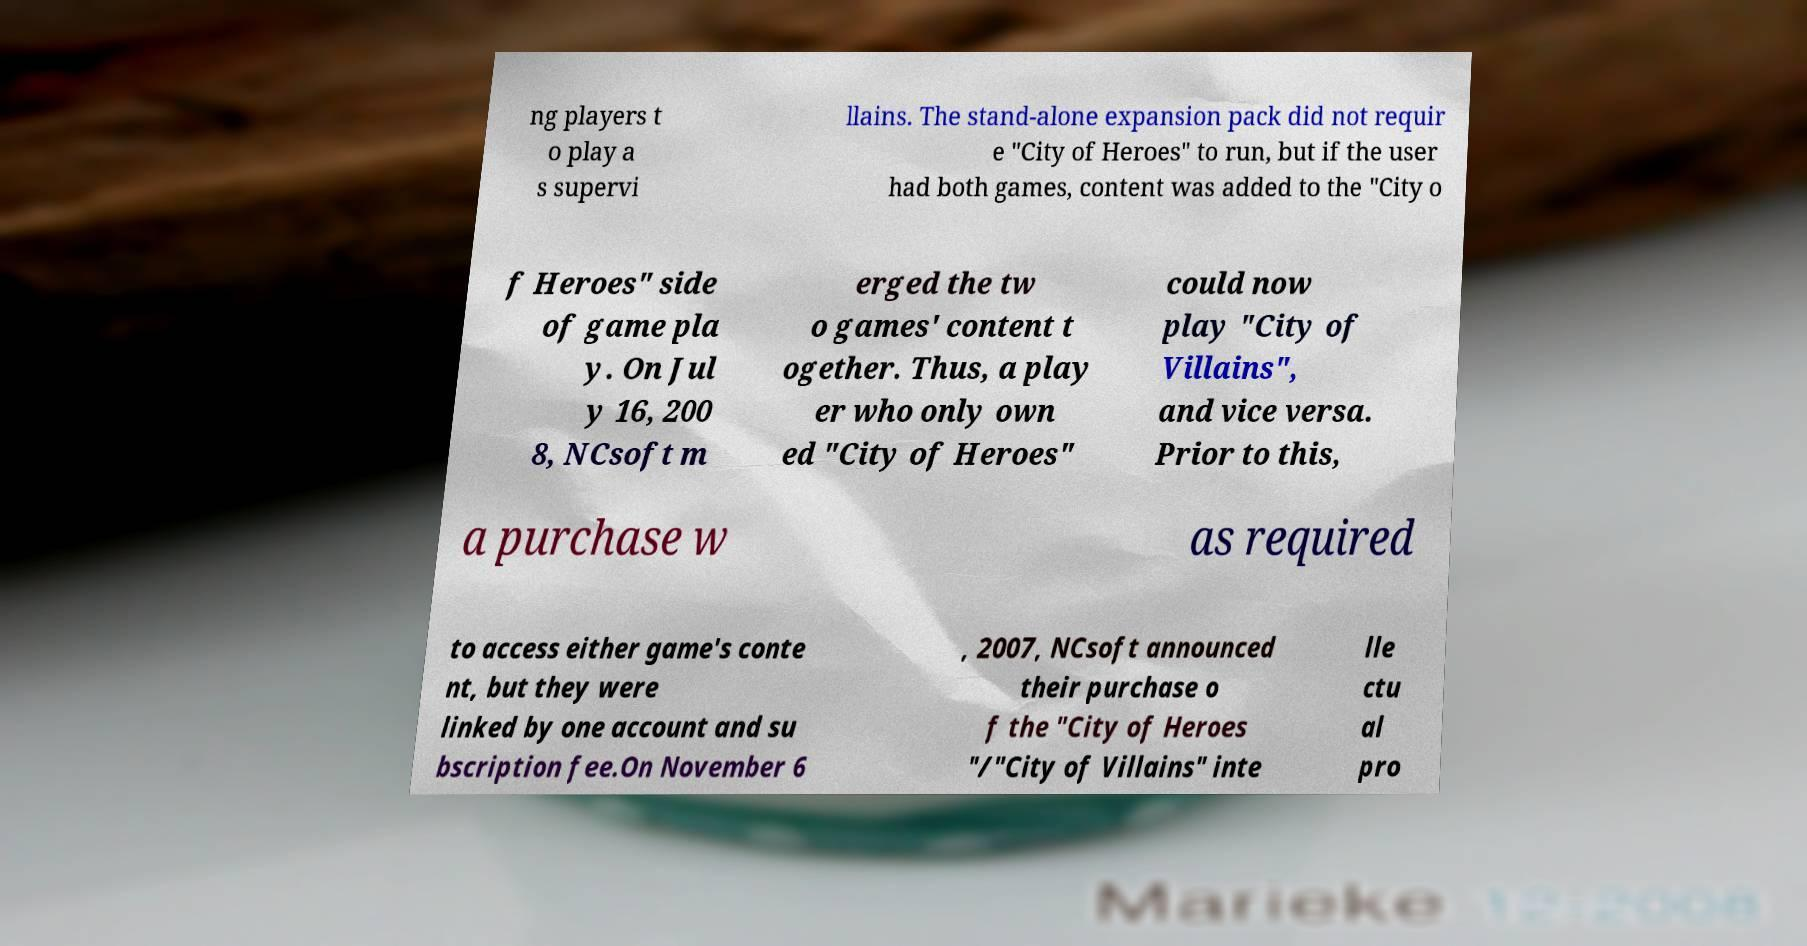Can you accurately transcribe the text from the provided image for me? ng players t o play a s supervi llains. The stand-alone expansion pack did not requir e "City of Heroes" to run, but if the user had both games, content was added to the "City o f Heroes" side of game pla y. On Jul y 16, 200 8, NCsoft m erged the tw o games' content t ogether. Thus, a play er who only own ed "City of Heroes" could now play "City of Villains", and vice versa. Prior to this, a purchase w as required to access either game's conte nt, but they were linked by one account and su bscription fee.On November 6 , 2007, NCsoft announced their purchase o f the "City of Heroes "/"City of Villains" inte lle ctu al pro 